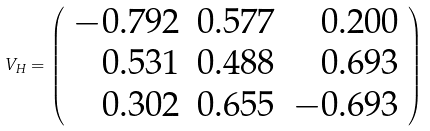Convert formula to latex. <formula><loc_0><loc_0><loc_500><loc_500>V _ { H } = \left ( \begin{array} { r r r } { - 0 . 7 9 2 } & { 0 . 5 7 7 } & 0 . 2 0 0 \\ { 0 . 5 3 1 } & { 0 . 4 8 8 } & 0 . 6 9 3 \\ { 0 . 3 0 2 } & { 0 . 6 5 5 } & - 0 . 6 9 3 \end{array} \right )</formula> 